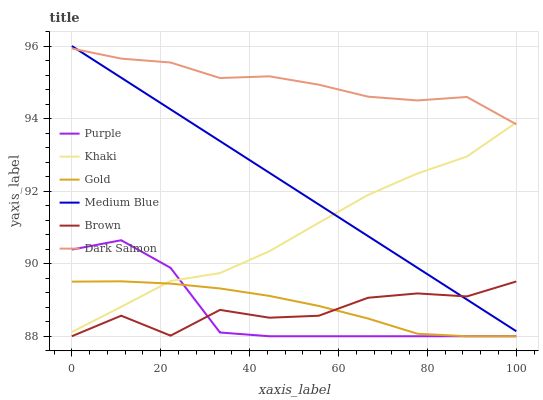Does Purple have the minimum area under the curve?
Answer yes or no. Yes. Does Dark Salmon have the maximum area under the curve?
Answer yes or no. Yes. Does Khaki have the minimum area under the curve?
Answer yes or no. No. Does Khaki have the maximum area under the curve?
Answer yes or no. No. Is Medium Blue the smoothest?
Answer yes or no. Yes. Is Brown the roughest?
Answer yes or no. Yes. Is Khaki the smoothest?
Answer yes or no. No. Is Khaki the roughest?
Answer yes or no. No. Does Brown have the lowest value?
Answer yes or no. Yes. Does Khaki have the lowest value?
Answer yes or no. No. Does Medium Blue have the highest value?
Answer yes or no. Yes. Does Khaki have the highest value?
Answer yes or no. No. Is Gold less than Dark Salmon?
Answer yes or no. Yes. Is Medium Blue greater than Gold?
Answer yes or no. Yes. Does Dark Salmon intersect Khaki?
Answer yes or no. Yes. Is Dark Salmon less than Khaki?
Answer yes or no. No. Is Dark Salmon greater than Khaki?
Answer yes or no. No. Does Gold intersect Dark Salmon?
Answer yes or no. No. 